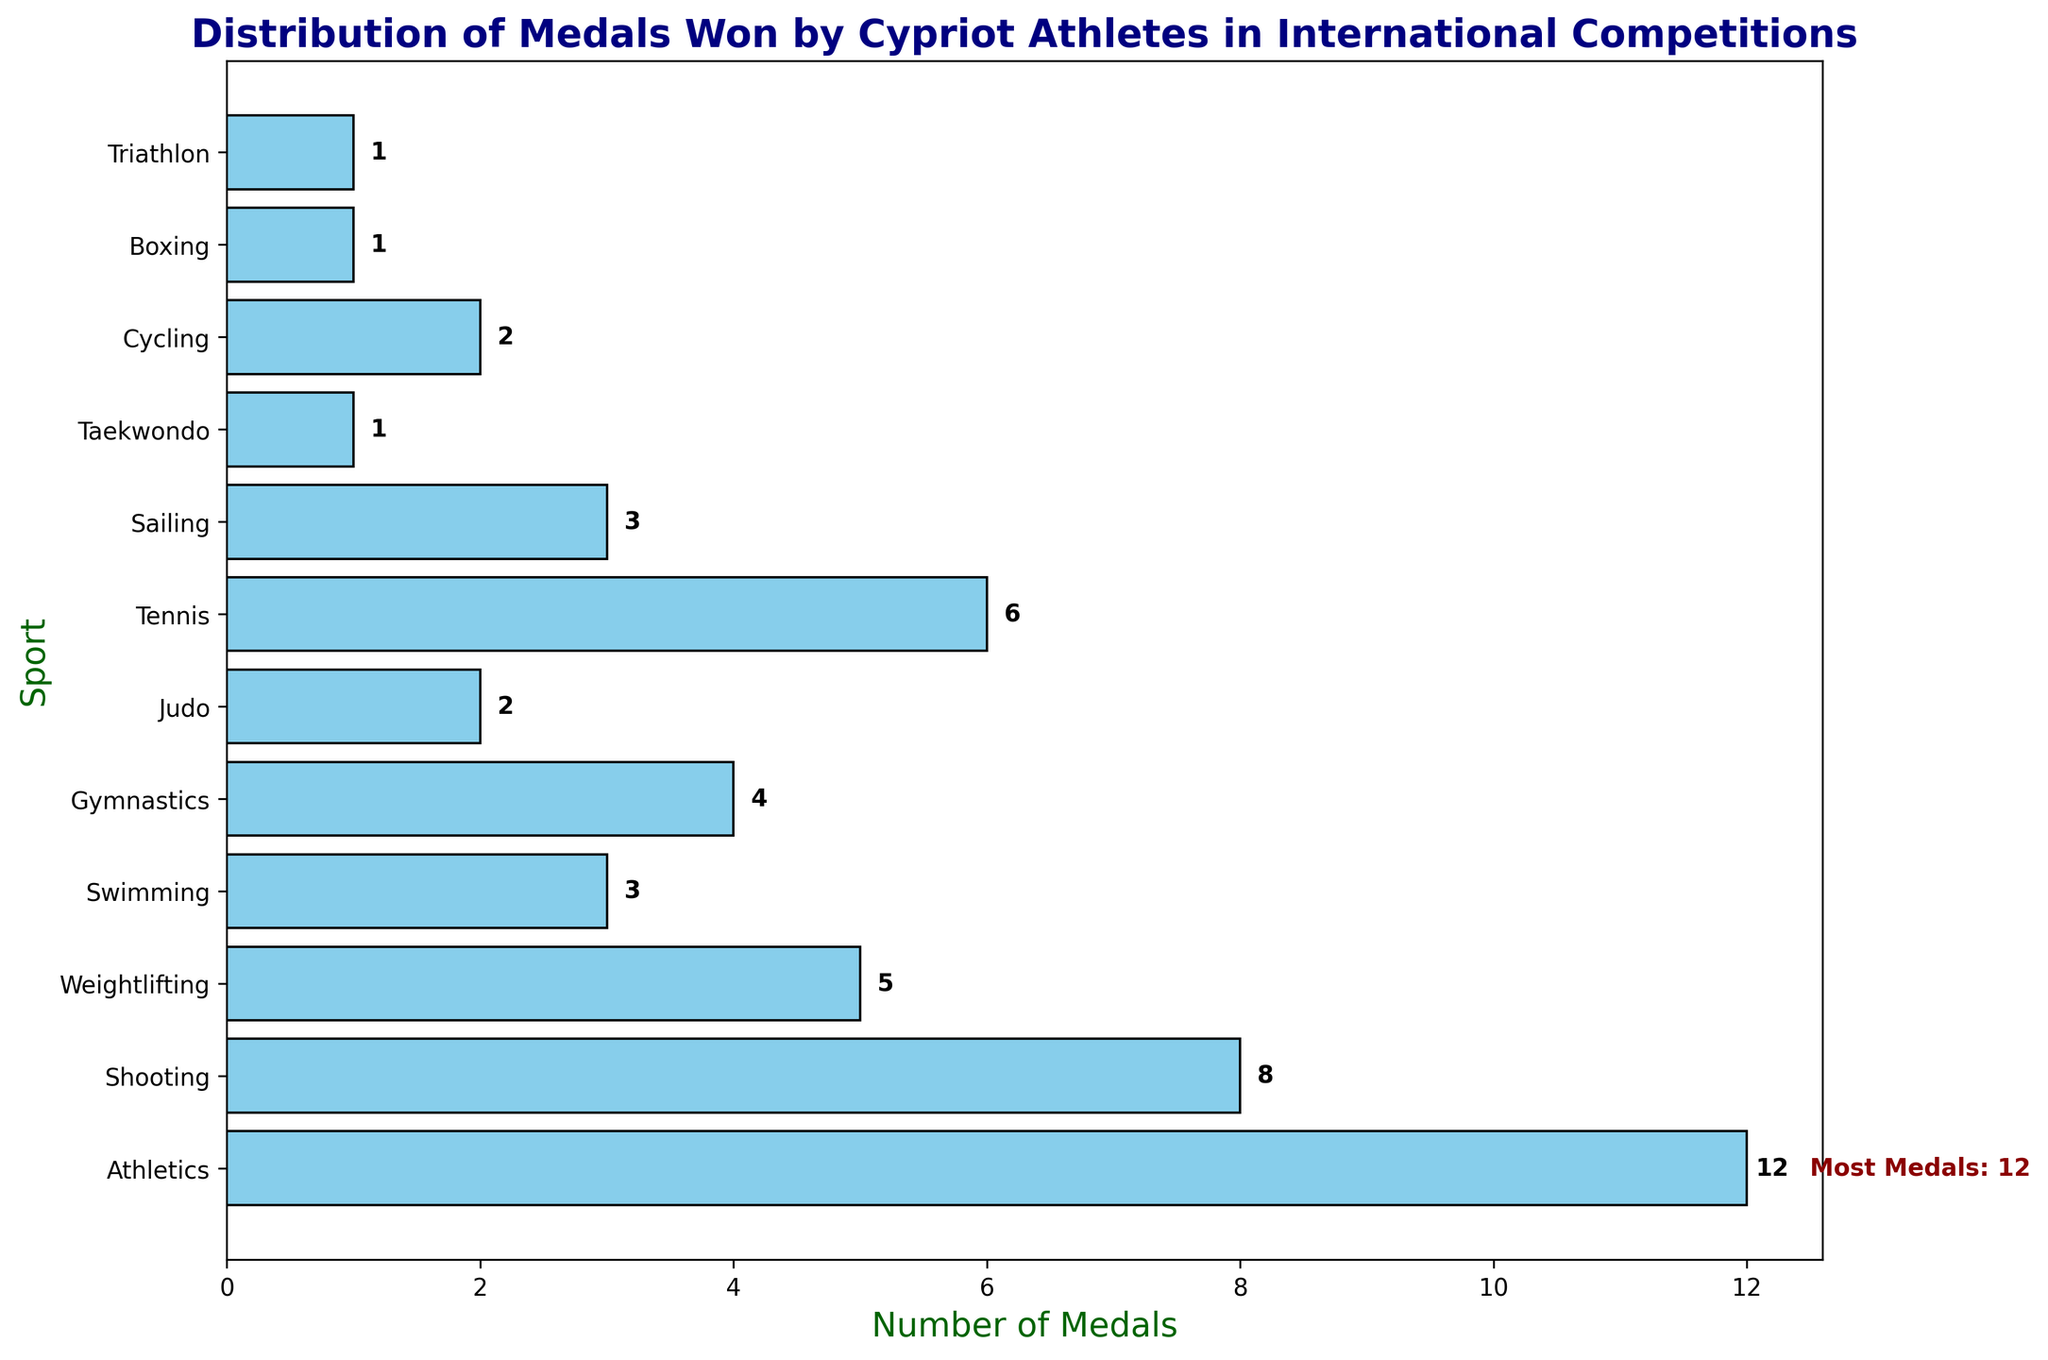Which sport has won the most medals? Refer to the figure and notice the text annotation next to the longest bar, which indicates the sport with the most medals. The annotation "Most Medals: 12" points to Athletics.
Answer: Athletics How many more medals has Athletics won compared to Swimming? From the figure, Athletics has 12 medals and Swimming has 3. Subtract Swimming's medals from Athletics' medals: 12 - 3 = 9.
Answer: 9 Which two sports have won an equal number of medals, and how many have they won? Look for sports with bars of the same length. Both Judo and Cycling have 2 medals each.
Answer: Judo and Cycling, 2 What's the total number of medals won by the top three sports? Identify the top three sports by looking at the longest bars: Athletics (12), Shooting (8), and Tennis (6). Sum them up: 12 + 8 + 6 = 26.
Answer: 26 Which sport has won the least number of medals? Identify the shortest bars. Taekwondo, Boxing, and Triathlon each have 1 medal.
Answer: Taekwondo, Boxing, Triathlon How many sports have won at least 5 medals? Count the bars that extend up to 5 or more medals: Athletics (12), Shooting (8), Weightlifting (5), and Tennis (6). Four sports have won at least 5 medals.
Answer: 4 Compare the number of medals won by Gymnastics and Sailing. Which sport has more, and by how much? Gymnastics has 4 medals while Sailing has 3. The difference: 4 - 3 = 1. Gymnastics has 1 more medal.
Answer: Gymnastics, 1 What's the average number of medals won by all sports? Sum all the medals and divide by the number of sports: (12 + 8 + 5 + 3 + 4 + 2 + 6 + 3 + 1 + 2 + 1 + 1) = 48; 48 / 12 = 4.
Answer: 4 Name the sports that have won exactly 3 medals. Identify the bars that extend to 3 medals: Swimming and Sailing.
Answer: Swimming, Sailing Which sport ranks second in the number of medals won and how many medals does it have? The second longest bar is for Shooting, which has 8 medals.
Answer: Shooting, 8 